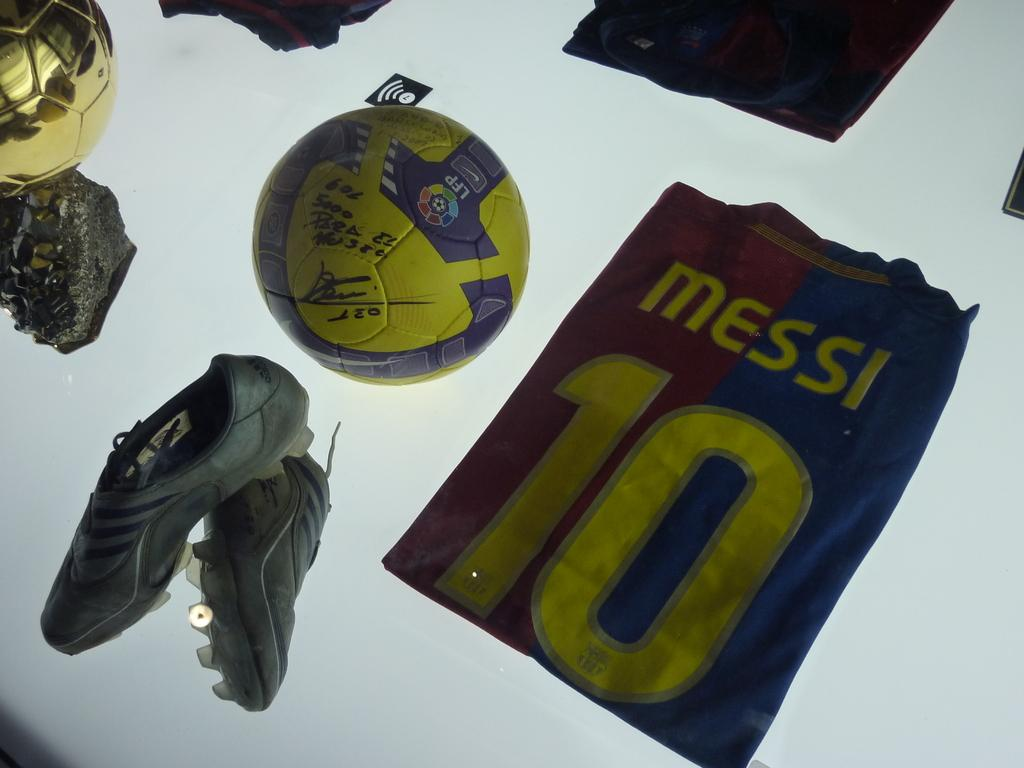What object can be seen in the image? There is a ball in the image. What else is related to sports in the image? There is a group of jerseys in the image. What type of footwear is present in the image? Shoes are present in the image. Where are the shoes located in the image? The shoes are placed on a table. What type of art can be seen on the shoes in the image? There is no art present on the shoes in the image; they are not mentioned as having any decorative elements. 